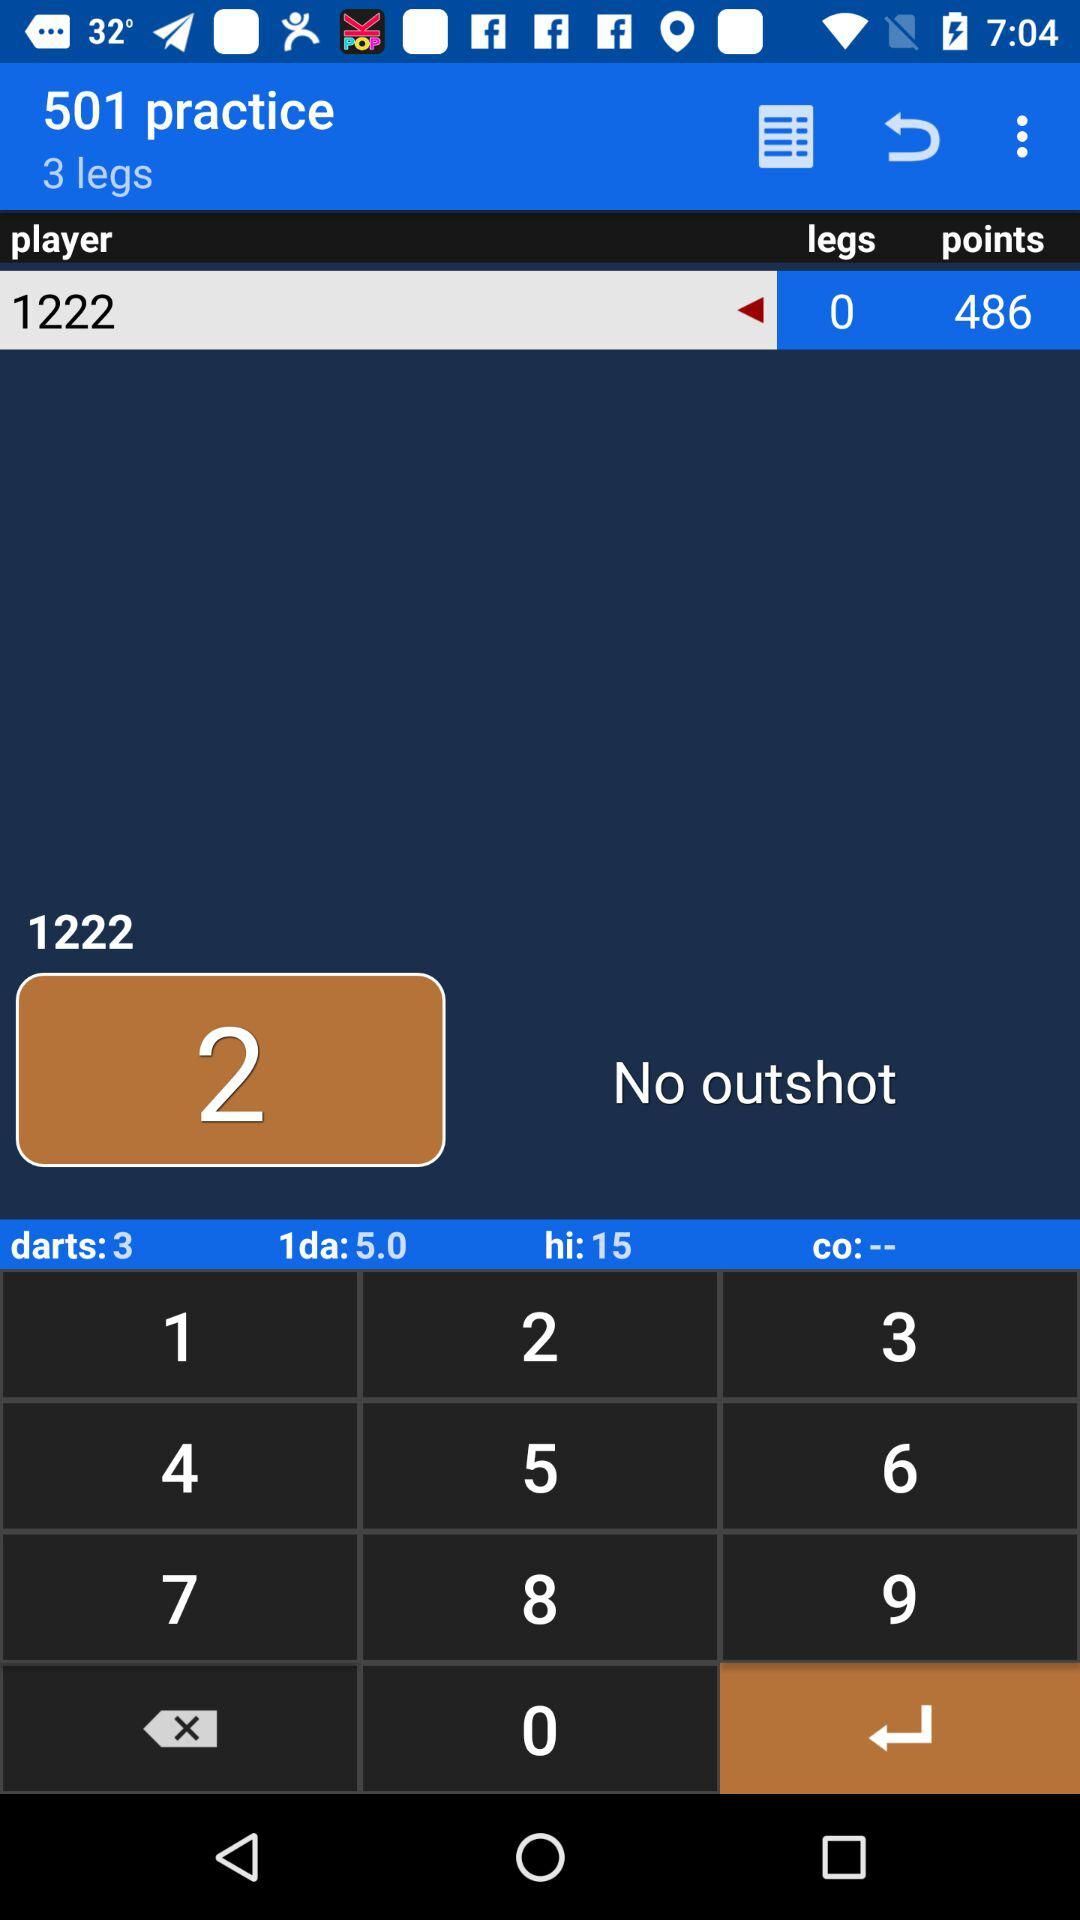How many points in total are there? There are 486 points. 